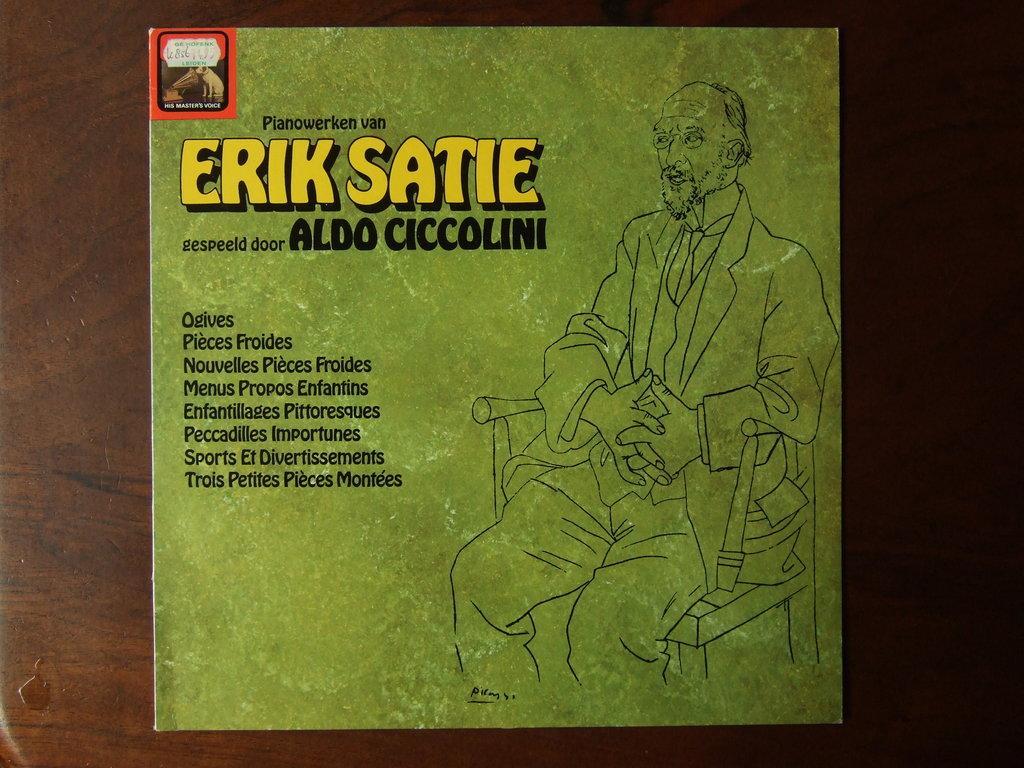In one or two sentences, can you explain what this image depicts? In this picture there is a table, on that table, we can see a paper. On that paper there is a painting of a man sitting on the chair. On the left side, we can also see a water drop. 